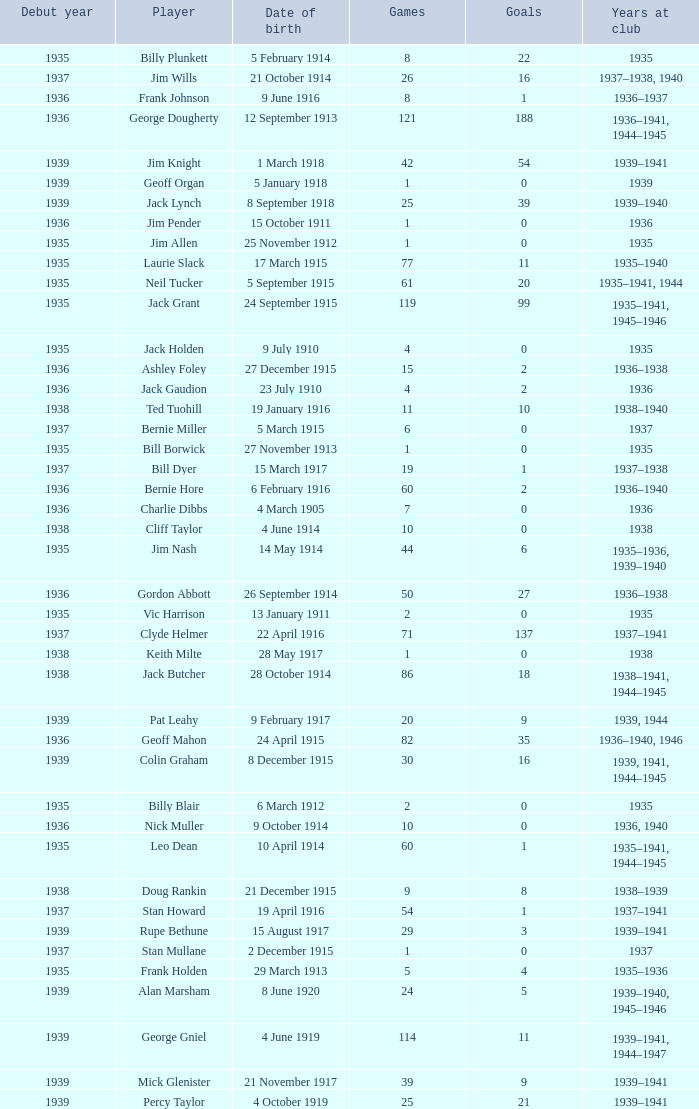I'm looking to parse the entire table for insights. Could you assist me with that? {'header': ['Debut year', 'Player', 'Date of birth', 'Games', 'Goals', 'Years at club'], 'rows': [['1935', 'Billy Plunkett', '5 February 1914', '8', '22', '1935'], ['1937', 'Jim Wills', '21 October 1914', '26', '16', '1937–1938, 1940'], ['1936', 'Frank Johnson', '9 June 1916', '8', '1', '1936–1937'], ['1936', 'George Dougherty', '12 September 1913', '121', '188', '1936–1941, 1944–1945'], ['1939', 'Jim Knight', '1 March 1918', '42', '54', '1939–1941'], ['1939', 'Geoff Organ', '5 January 1918', '1', '0', '1939'], ['1939', 'Jack Lynch', '8 September 1918', '25', '39', '1939–1940'], ['1936', 'Jim Pender', '15 October 1911', '1', '0', '1936'], ['1935', 'Jim Allen', '25 November 1912', '1', '0', '1935'], ['1935', 'Laurie Slack', '17 March 1915', '77', '11', '1935–1940'], ['1935', 'Neil Tucker', '5 September 1915', '61', '20', '1935–1941, 1944'], ['1935', 'Jack Grant', '24 September 1915', '119', '99', '1935–1941, 1945–1946'], ['1935', 'Jack Holden', '9 July 1910', '4', '0', '1935'], ['1936', 'Ashley Foley', '27 December 1915', '15', '2', '1936–1938'], ['1936', 'Jack Gaudion', '23 July 1910', '4', '2', '1936'], ['1938', 'Ted Tuohill', '19 January 1916', '11', '10', '1938–1940'], ['1937', 'Bernie Miller', '5 March 1915', '6', '0', '1937'], ['1935', 'Bill Borwick', '27 November 1913', '1', '0', '1935'], ['1937', 'Bill Dyer', '15 March 1917', '19', '1', '1937–1938'], ['1936', 'Bernie Hore', '6 February 1916', '60', '2', '1936–1940'], ['1936', 'Charlie Dibbs', '4 March 1905', '7', '0', '1936'], ['1938', 'Cliff Taylor', '4 June 1914', '10', '0', '1938'], ['1935', 'Jim Nash', '14 May 1914', '44', '6', '1935–1936, 1939–1940'], ['1936', 'Gordon Abbott', '26 September 1914', '50', '27', '1936–1938'], ['1935', 'Vic Harrison', '13 January 1911', '2', '0', '1935'], ['1937', 'Clyde Helmer', '22 April 1916', '71', '137', '1937–1941'], ['1938', 'Keith Milte', '28 May 1917', '1', '0', '1938'], ['1938', 'Jack Butcher', '28 October 1914', '86', '18', '1938–1941, 1944–1945'], ['1939', 'Pat Leahy', '9 February 1917', '20', '9', '1939, 1944'], ['1936', 'Geoff Mahon', '24 April 1915', '82', '35', '1936–1940, 1946'], ['1939', 'Colin Graham', '8 December 1915', '30', '16', '1939, 1941, 1944–1945'], ['1935', 'Billy Blair', '6 March 1912', '2', '0', '1935'], ['1936', 'Nick Muller', '9 October 1914', '10', '0', '1936, 1940'], ['1935', 'Leo Dean', '10 April 1914', '60', '1', '1935–1941, 1944–1945'], ['1938', 'Doug Rankin', '21 December 1915', '9', '8', '1938–1939'], ['1937', 'Stan Howard', '19 April 1916', '54', '1', '1937–1941'], ['1939', 'Rupe Bethune', '15 August 1917', '29', '3', '1939–1941'], ['1937', 'Stan Mullane', '2 December 1915', '1', '0', '1937'], ['1935', 'Frank Holden', '29 March 1913', '5', '4', '1935–1936'], ['1939', 'Alan Marsham', '8 June 1920', '24', '5', '1939–1940, 1945–1946'], ['1939', 'George Gniel', '4 June 1919', '114', '11', '1939–1941, 1944–1947'], ['1939', 'Mick Glenister', '21 November 1917', '39', '9', '1939–1941'], ['1939', 'Percy Taylor', '4 October 1919', '25', '21', '1939–1941']]} What is the lowest number of games Jack Gaudion, who debut in 1936, played? 4.0. 